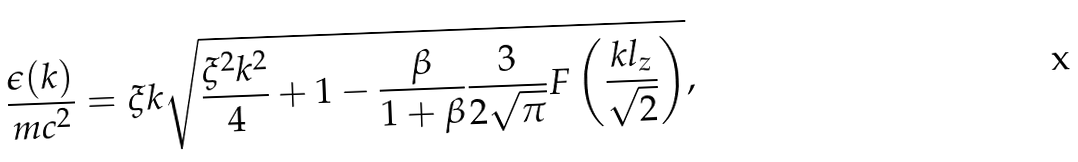Convert formula to latex. <formula><loc_0><loc_0><loc_500><loc_500>\frac { \epsilon ( k ) } { m c ^ { 2 } } = \xi k \sqrt { \frac { \xi ^ { 2 } k ^ { 2 } } { 4 } + 1 - \frac { \beta } { 1 + \beta } \frac { 3 } { 2 \sqrt { \pi } } F \left ( \frac { k l _ { z } } { \sqrt { 2 } } \right ) } ,</formula> 